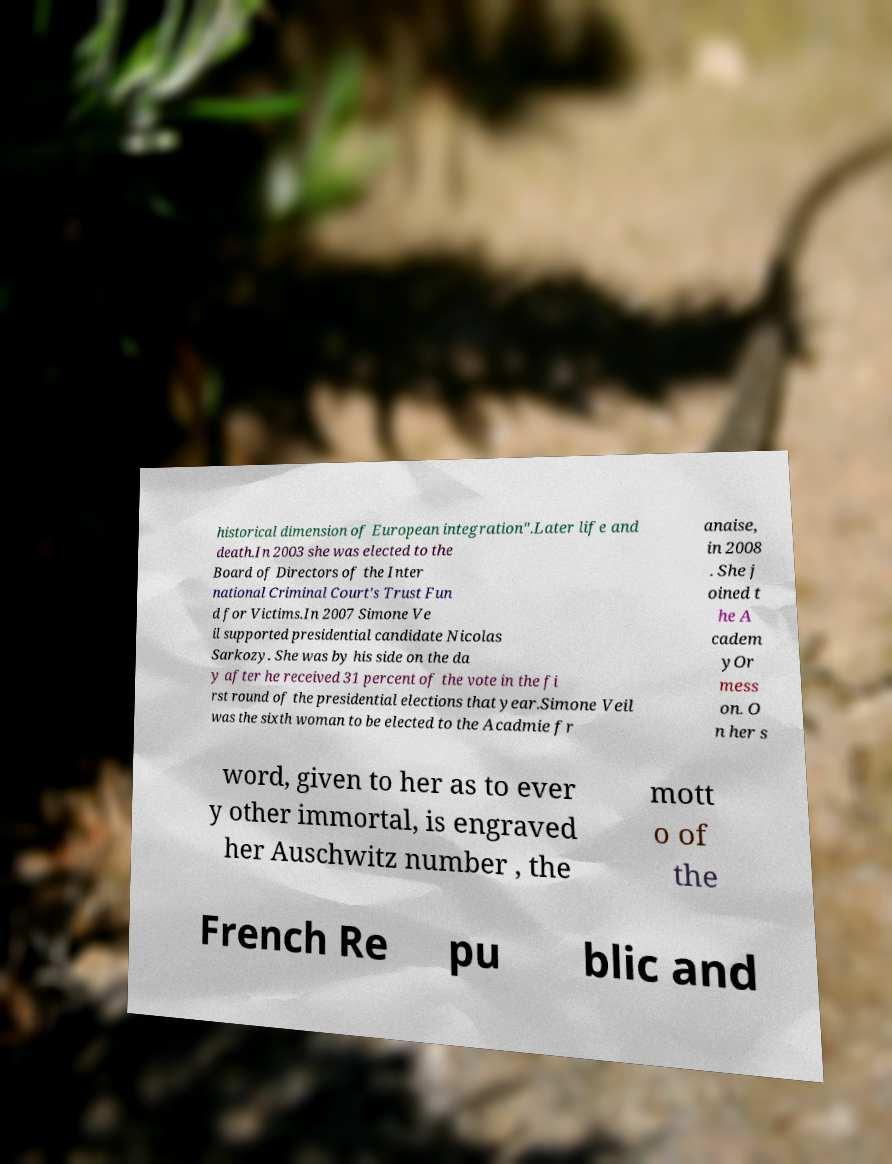Could you extract and type out the text from this image? historical dimension of European integration".Later life and death.In 2003 she was elected to the Board of Directors of the Inter national Criminal Court's Trust Fun d for Victims.In 2007 Simone Ve il supported presidential candidate Nicolas Sarkozy. She was by his side on the da y after he received 31 percent of the vote in the fi rst round of the presidential elections that year.Simone Veil was the sixth woman to be elected to the Acadmie fr anaise, in 2008 . She j oined t he A cadem yOr mess on. O n her s word, given to her as to ever y other immortal, is engraved her Auschwitz number , the mott o of the French Re pu blic and 